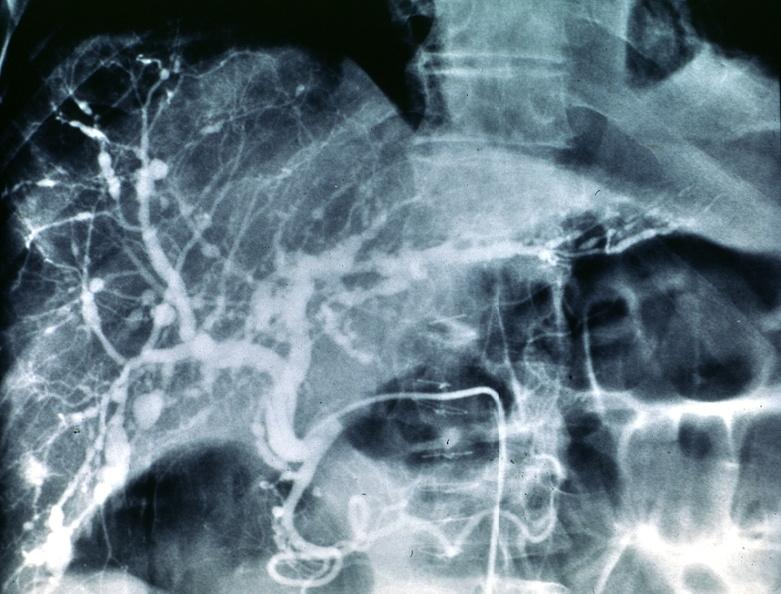what does this image show?
Answer the question using a single word or phrase. Polyarteritis nodosa 